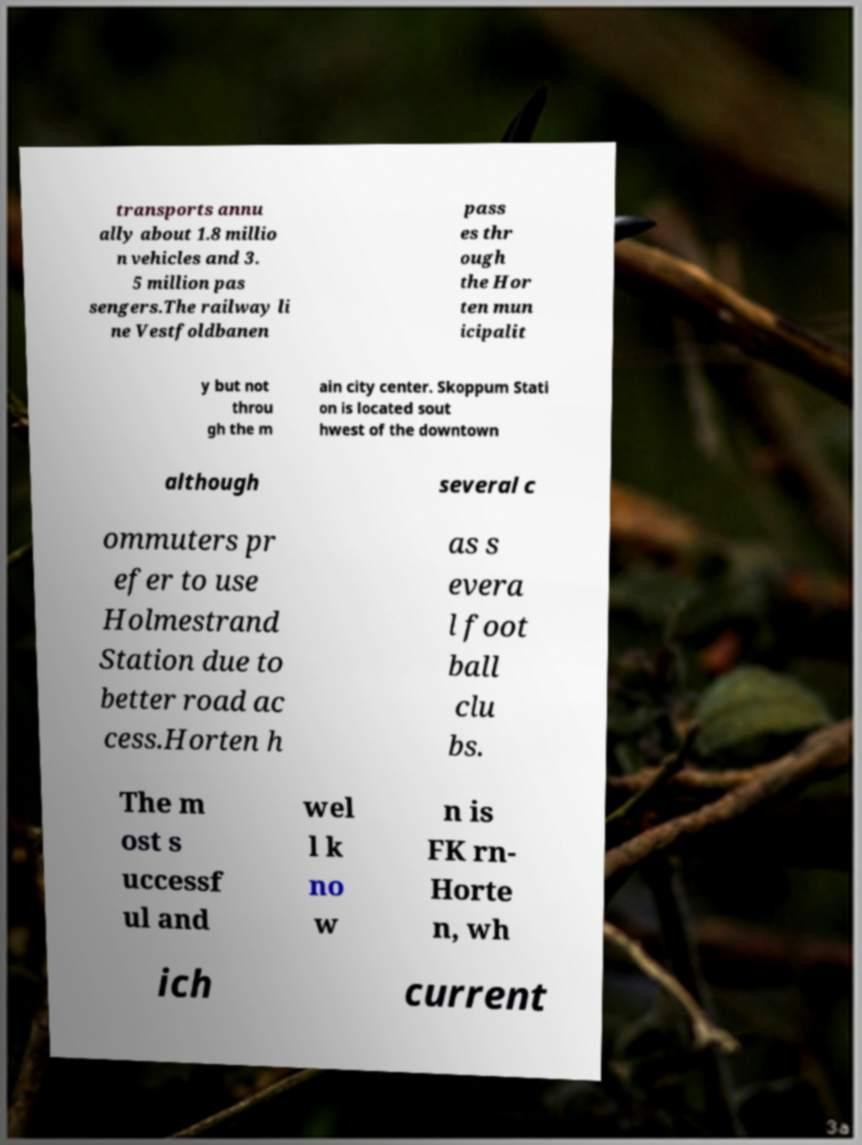For documentation purposes, I need the text within this image transcribed. Could you provide that? transports annu ally about 1.8 millio n vehicles and 3. 5 million pas sengers.The railway li ne Vestfoldbanen pass es thr ough the Hor ten mun icipalit y but not throu gh the m ain city center. Skoppum Stati on is located sout hwest of the downtown although several c ommuters pr efer to use Holmestrand Station due to better road ac cess.Horten h as s evera l foot ball clu bs. The m ost s uccessf ul and wel l k no w n is FK rn- Horte n, wh ich current 